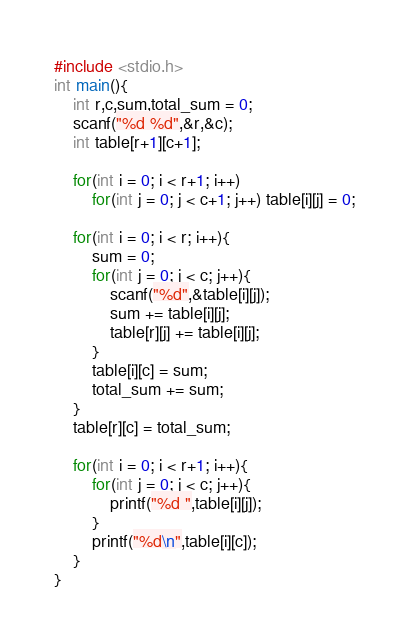<code> <loc_0><loc_0><loc_500><loc_500><_C_>#include <stdio.h>
int main(){
	int r,c,sum,total_sum = 0;
	scanf("%d %d",&r,&c);
	int table[r+1][c+1];

	for(int i = 0; i < r+1; i++)
		for(int j = 0; j < c+1; j++) table[i][j] = 0;

	for(int i = 0; i < r; i++){
		sum = 0;
		for(int j = 0; j < c; j++){
			scanf("%d",&table[i][j]);
			sum += table[i][j];
			table[r][j] += table[i][j];
		}
		table[i][c] = sum;
		total_sum += sum;
	}
	table[r][c] = total_sum;

	for(int i = 0; i < r+1; i++){
		for(int j = 0; j < c; j++){
			printf("%d ",table[i][j]);
		}
		printf("%d\n",table[i][c]);
	}
}


</code> 